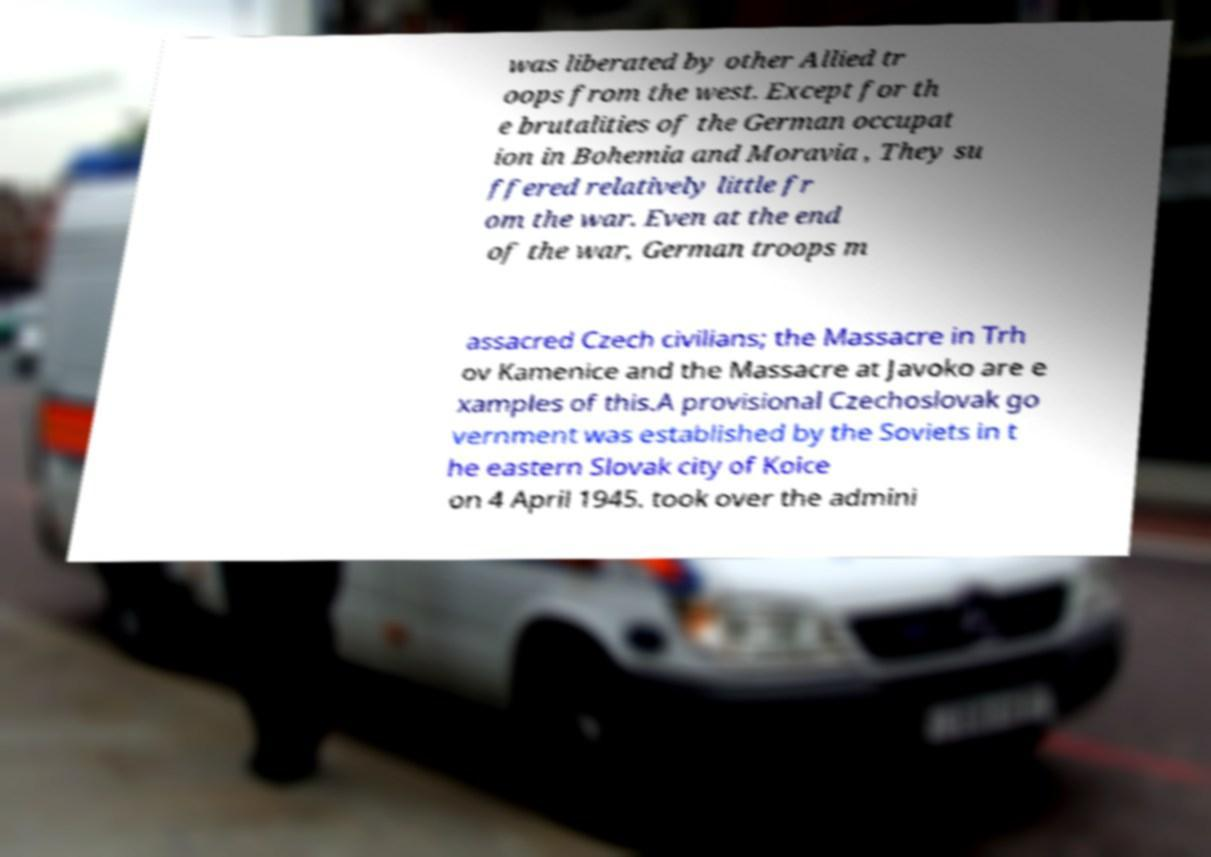Can you read and provide the text displayed in the image?This photo seems to have some interesting text. Can you extract and type it out for me? was liberated by other Allied tr oops from the west. Except for th e brutalities of the German occupat ion in Bohemia and Moravia , They su ffered relatively little fr om the war. Even at the end of the war, German troops m assacred Czech civilians; the Massacre in Trh ov Kamenice and the Massacre at Javoko are e xamples of this.A provisional Czechoslovak go vernment was established by the Soviets in t he eastern Slovak city of Koice on 4 April 1945. took over the admini 